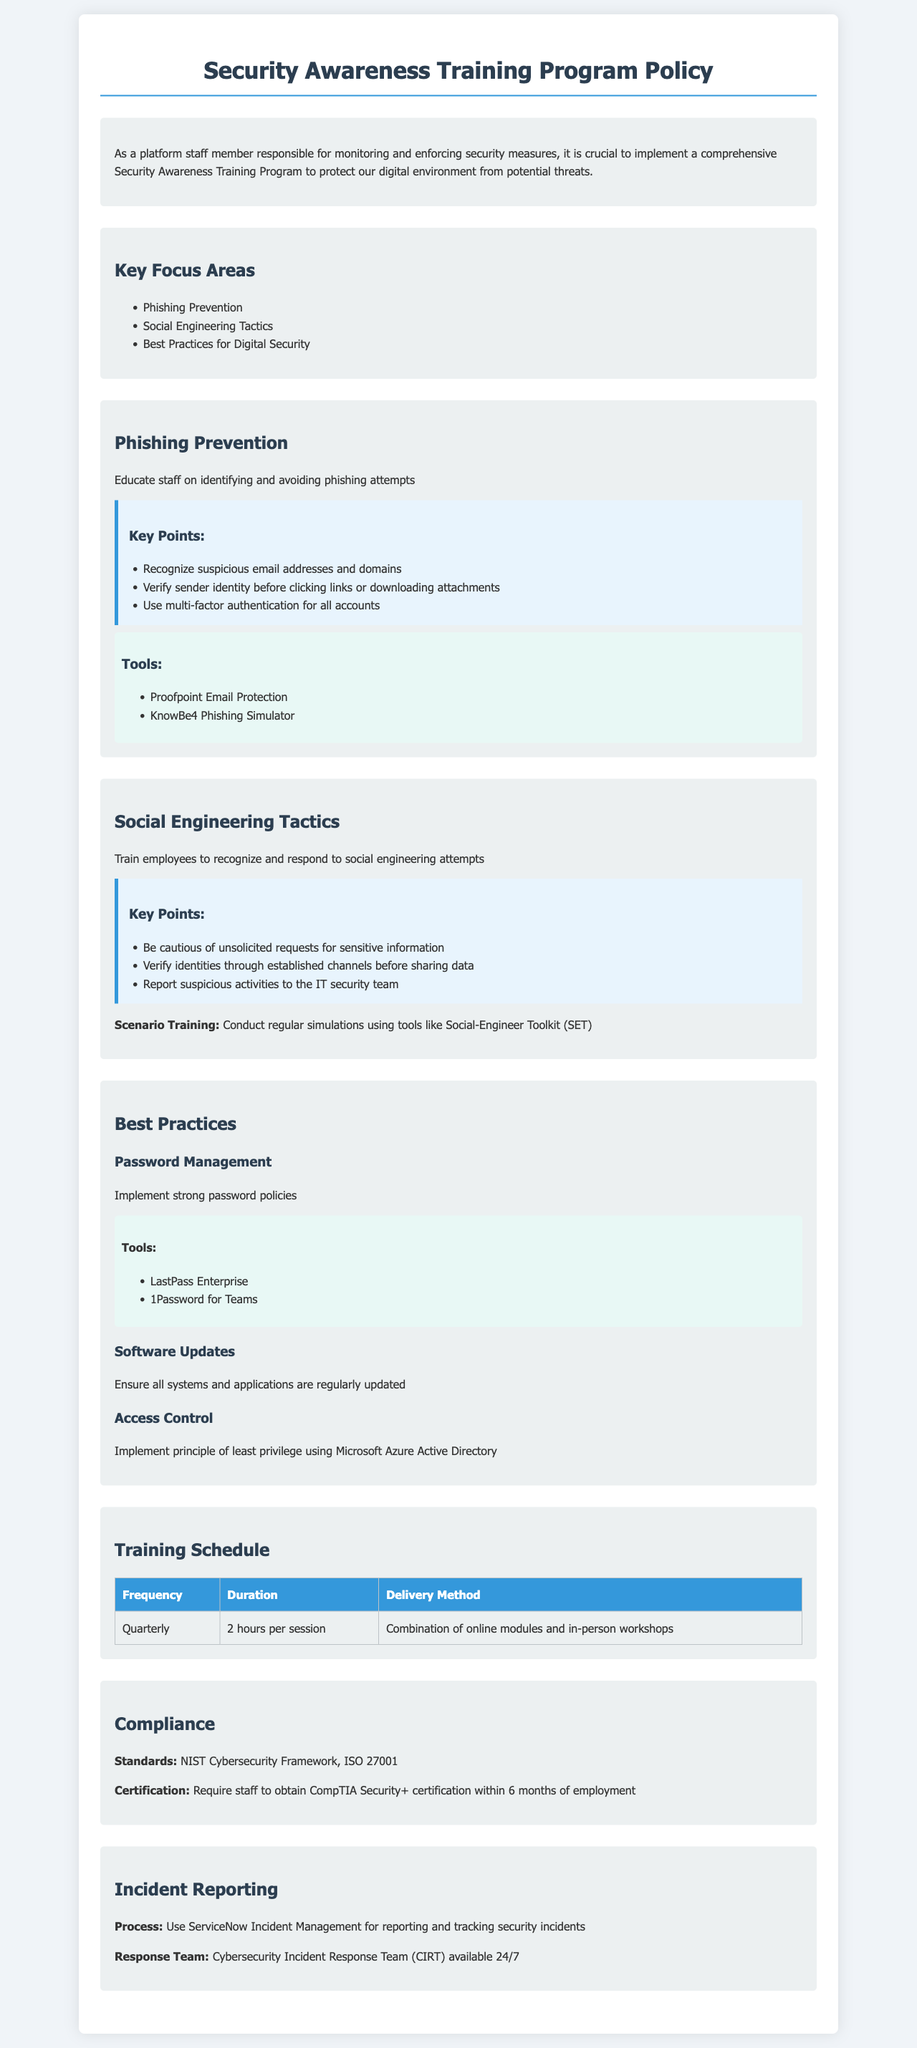what are the key focus areas of the training program? The key focus areas are outlined in a list format under "Key Focus Areas," which includes phishing prevention, social engineering tactics, and best practices for digital security.
Answer: Phishing Prevention, Social Engineering Tactics, Best Practices for Digital Security what tools are recommended for phishing prevention? The tools are listed in the "Tools" section under "Phishing Prevention," specifically mentioning two tools used for training staff on phishing.
Answer: Proofpoint Email Protection, KnowBe4 Phishing Simulator how often is the training scheduled? The frequency of the training is indicated in the "Training Schedule" section, specifying how often the training takes place.
Answer: Quarterly what is the duration of each training session? The duration is provided in the training schedule, specifying how long each session lasts.
Answer: 2 hours per session what compliance standards are referenced in the document? The compliance standards are mentioned in the "Compliance" section, specifying which standards the program adheres to.
Answer: NIST Cybersecurity Framework, ISO 27001 what is the required certification for staff within six months? The required certification is listed in the "Compliance" section, specifying the name of the certification staff must obtain.
Answer: CompTIA Security+ what is the purpose of the cybersecurity incident response team? The purpose of the team is defined in the "Incident Reporting" section, specifically explaining the team's availability to address security concerns.
Answer: Available 24/7 what is the title of the document? The title is explicitly stated at the top of the document.
Answer: Security Awareness Training Program Policy 